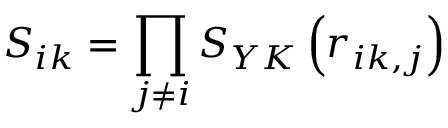<formula> <loc_0><loc_0><loc_500><loc_500>S _ { i k } = \prod _ { j \neq i } S _ { Y K } \left ( r _ { i k , j } \right )</formula> 